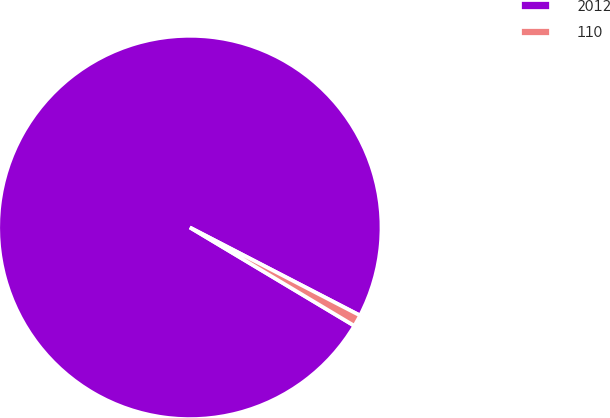Convert chart. <chart><loc_0><loc_0><loc_500><loc_500><pie_chart><fcel>2012<fcel>110<nl><fcel>99.02%<fcel>0.98%<nl></chart> 